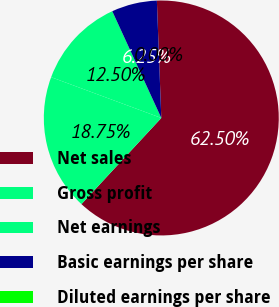<chart> <loc_0><loc_0><loc_500><loc_500><pie_chart><fcel>Net sales<fcel>Gross profit<fcel>Net earnings<fcel>Basic earnings per share<fcel>Diluted earnings per share<nl><fcel>62.5%<fcel>18.75%<fcel>12.5%<fcel>6.25%<fcel>0.0%<nl></chart> 